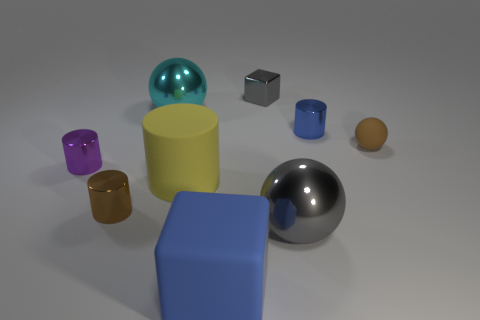Subtract 1 cylinders. How many cylinders are left? 3 Subtract all balls. How many objects are left? 6 Subtract 1 blue blocks. How many objects are left? 8 Subtract all large green rubber blocks. Subtract all large matte objects. How many objects are left? 7 Add 5 blue cylinders. How many blue cylinders are left? 6 Add 3 small purple metallic things. How many small purple metallic things exist? 4 